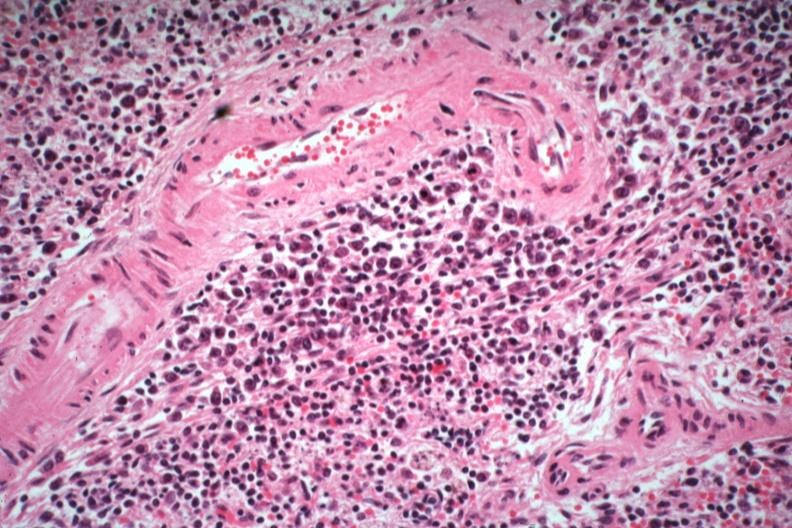what is numerous atypical cells around splenic arteriole man died?
Answer the question using a single word or phrase. Of what was thought to be viral pneumonia probably influenza 